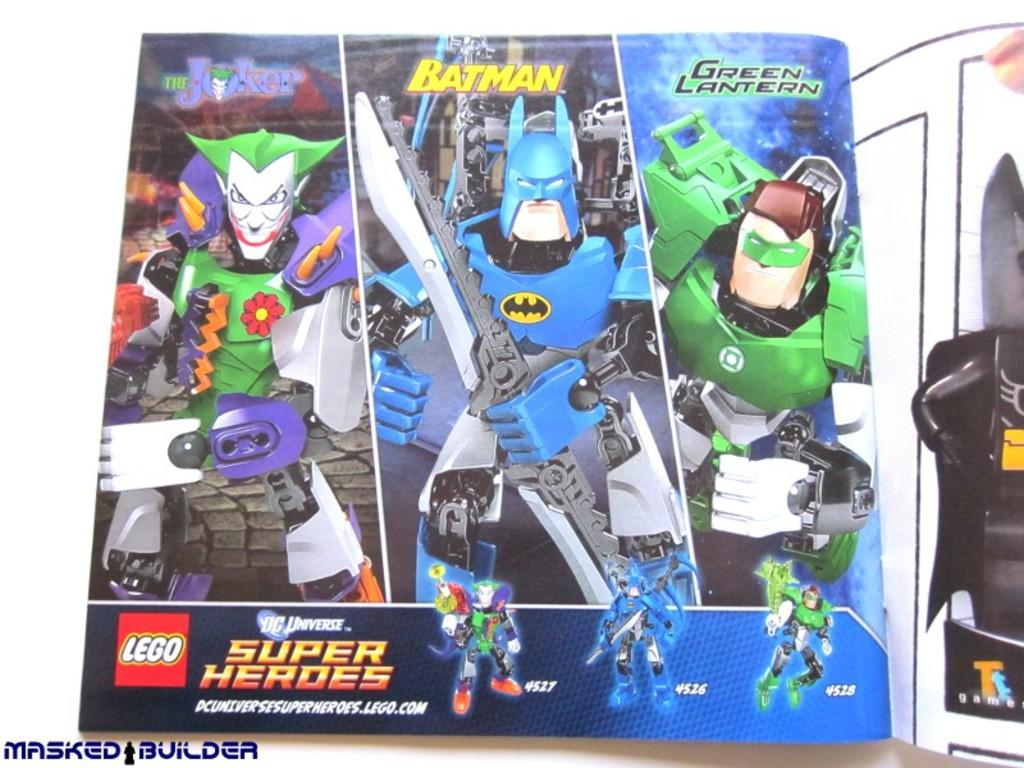What object can be seen in the image that might contain other items? There is a box in the image that might contain other items. What type of object is on the right side of the image? There is a toy on the right side of the image. Can you describe any additional features of the image? A watermark is visible in the image. What type of brick is used to build the shop in the image? There is no shop or brick present in the image. What specific detail can be seen on the toy in the image? The provided facts do not mention any specific details about the toy, so we cannot answer this question definitively. 